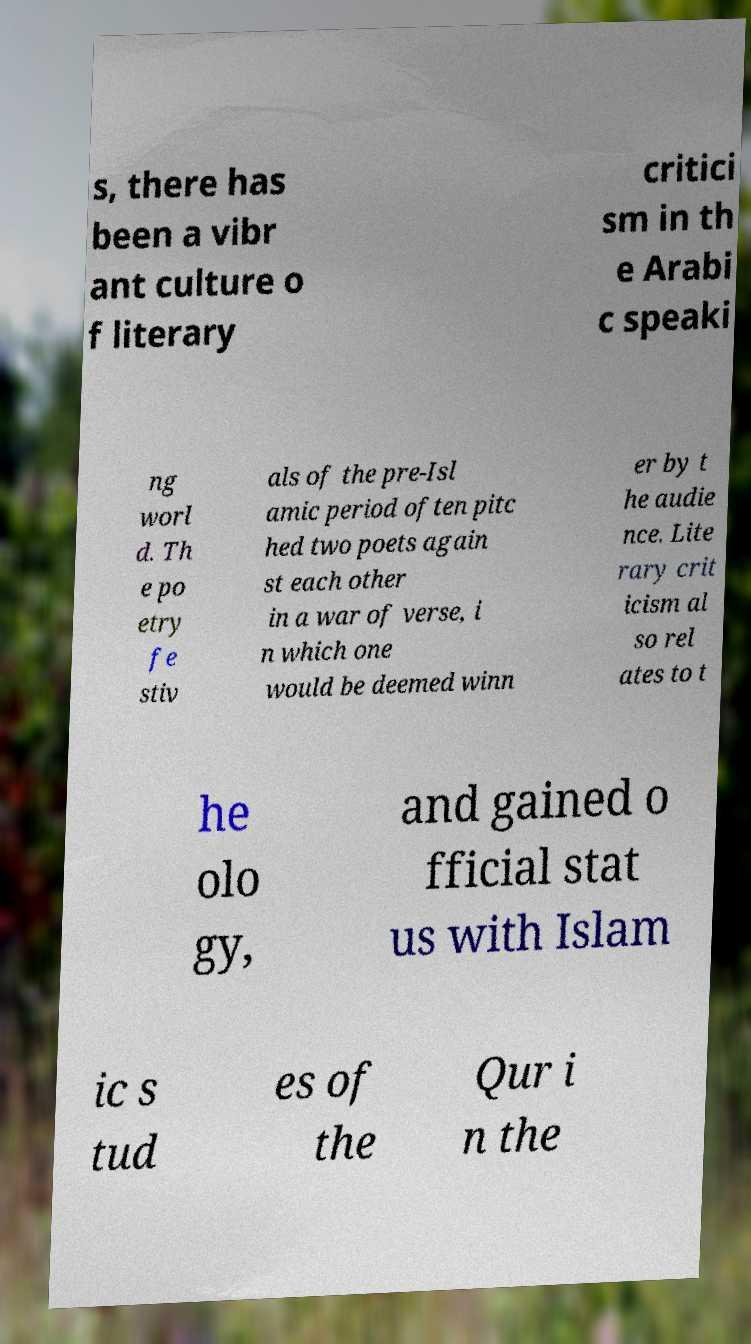Could you extract and type out the text from this image? s, there has been a vibr ant culture o f literary critici sm in th e Arabi c speaki ng worl d. Th e po etry fe stiv als of the pre-Isl amic period often pitc hed two poets again st each other in a war of verse, i n which one would be deemed winn er by t he audie nce. Lite rary crit icism al so rel ates to t he olo gy, and gained o fficial stat us with Islam ic s tud es of the Qur i n the 